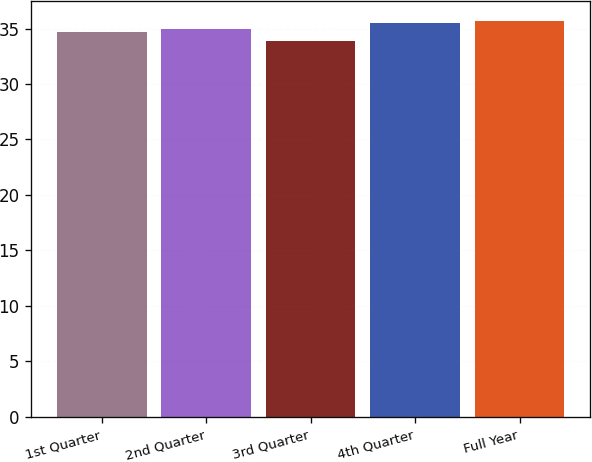Convert chart. <chart><loc_0><loc_0><loc_500><loc_500><bar_chart><fcel>1st Quarter<fcel>2nd Quarter<fcel>3rd Quarter<fcel>4th Quarter<fcel>Full Year<nl><fcel>34.68<fcel>34.98<fcel>33.92<fcel>35.5<fcel>35.66<nl></chart> 